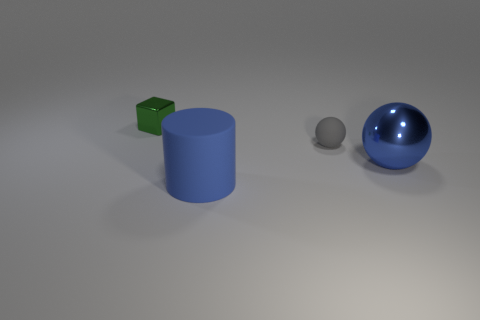What number of green blocks are the same size as the gray ball?
Offer a very short reply. 1. There is a large thing that is the same material as the gray ball; what color is it?
Give a very brief answer. Blue. Is the number of blue metal things left of the big metallic ball less than the number of large cyan rubber things?
Give a very brief answer. No. There is a object that is the same material as the gray sphere; what is its shape?
Your answer should be very brief. Cylinder. How many metal objects are small gray spheres or big blue cylinders?
Make the answer very short. 0. Are there the same number of blue matte objects that are to the left of the large rubber object and tiny red balls?
Provide a short and direct response. Yes. Does the metallic object on the right side of the blue matte cylinder have the same color as the large rubber object?
Ensure brevity in your answer.  Yes. What is the object that is in front of the gray ball and on the right side of the matte cylinder made of?
Make the answer very short. Metal. Are there any things that are to the left of the large thing to the left of the gray thing?
Your answer should be very brief. Yes. Does the green thing have the same material as the large ball?
Your answer should be very brief. Yes. 